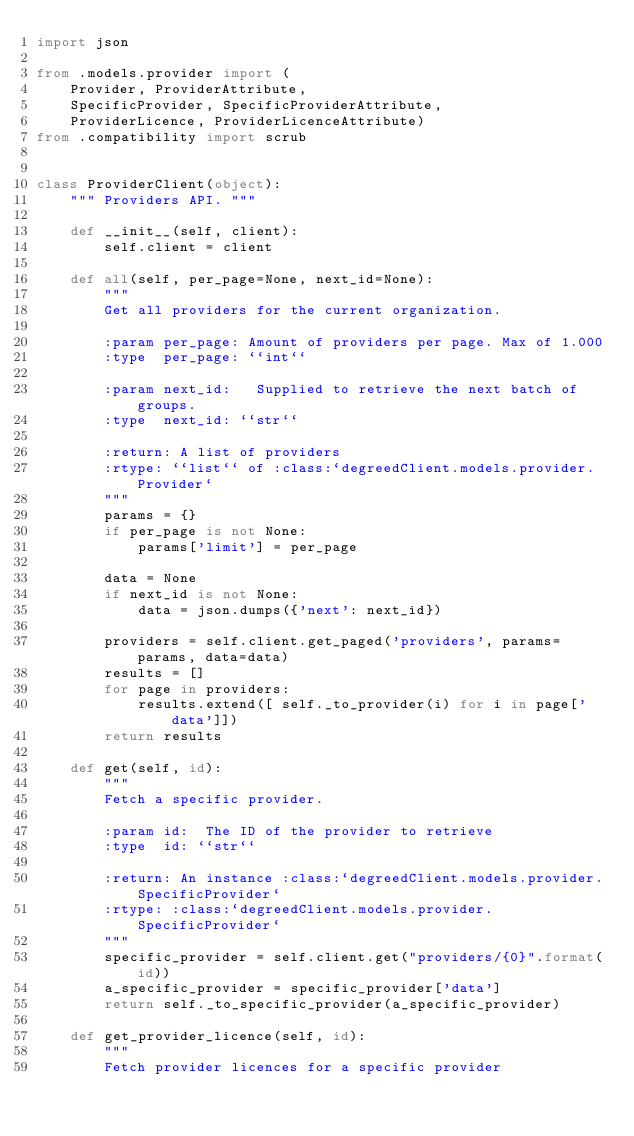<code> <loc_0><loc_0><loc_500><loc_500><_Python_>import json

from .models.provider import (
    Provider, ProviderAttribute,
    SpecificProvider, SpecificProviderAttribute,
    ProviderLicence, ProviderLicenceAttribute)
from .compatibility import scrub


class ProviderClient(object):
    """ Providers API. """

    def __init__(self, client):
        self.client = client

    def all(self, per_page=None, next_id=None):
        """
        Get all providers for the current organization.

        :param per_page: Amount of providers per page. Max of 1.000
        :type  per_page: ``int``

        :param next_id:   Supplied to retrieve the next batch of groups.
        :type  next_id: ``str``

        :return: A list of providers
        :rtype: ``list`` of :class:`degreedClient.models.provider.Provider`
        """
        params = {}
        if per_page is not None:
            params['limit'] = per_page

        data = None
        if next_id is not None:
            data = json.dumps({'next': next_id})

        providers = self.client.get_paged('providers', params=params, data=data)
        results = []
        for page in providers:
            results.extend([ self._to_provider(i) for i in page['data']])
        return results

    def get(self, id):
        """
        Fetch a specific provider.

        :param id:  The ID of the provider to retrieve
        :type  id: ``str``

        :return: An instance :class:`degreedClient.models.provider.SpecificProvider`
        :rtype: :class:`degreedClient.models.provider.SpecificProvider`
        """
        specific_provider = self.client.get("providers/{0}".format(id))
        a_specific_provider = specific_provider['data']
        return self._to_specific_provider(a_specific_provider)

    def get_provider_licence(self, id):
        """
        Fetch provider licences for a specific provider
</code> 